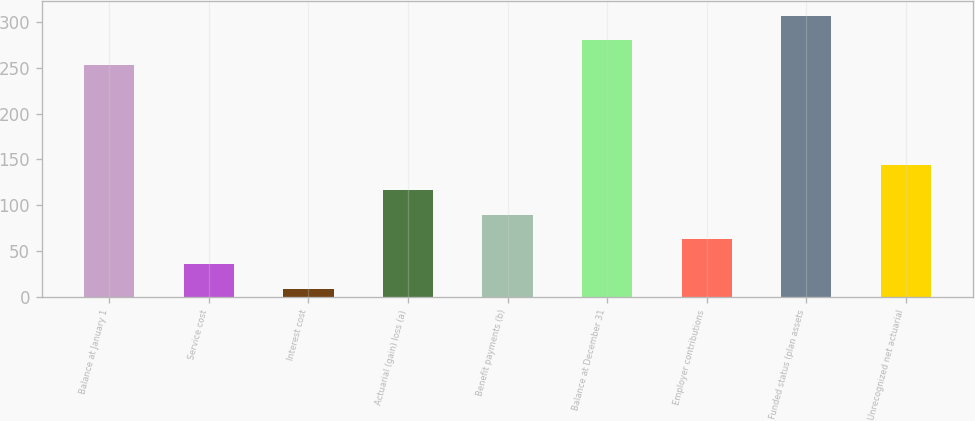<chart> <loc_0><loc_0><loc_500><loc_500><bar_chart><fcel>Balance at January 1<fcel>Service cost<fcel>Interest cost<fcel>Actuarial (gain) loss (a)<fcel>Benefit payments (b)<fcel>Balance at December 31<fcel>Employer contributions<fcel>Funded status (plan assets<fcel>Unrecognized net actuarial<nl><fcel>253<fcel>35.9<fcel>9<fcel>116.6<fcel>89.7<fcel>279.9<fcel>62.8<fcel>306.8<fcel>143.5<nl></chart> 